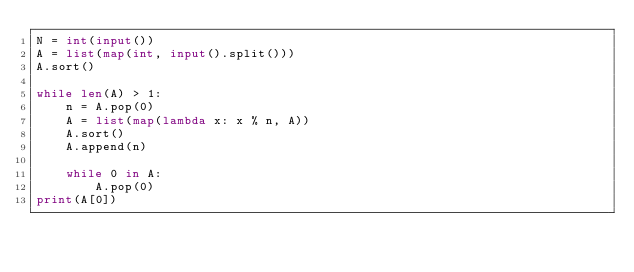Convert code to text. <code><loc_0><loc_0><loc_500><loc_500><_Python_>N = int(input())
A = list(map(int, input().split()))
A.sort()

while len(A) > 1:
    n = A.pop(0)
    A = list(map(lambda x: x % n, A))
    A.sort()
    A.append(n)

    while 0 in A:
        A.pop(0)
print(A[0])
</code> 